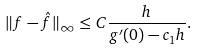<formula> <loc_0><loc_0><loc_500><loc_500>\| f - \hat { f } \| _ { \infty } \leq C \frac { h } { g ^ { \prime } ( 0 ) - c _ { 1 } h } .</formula> 